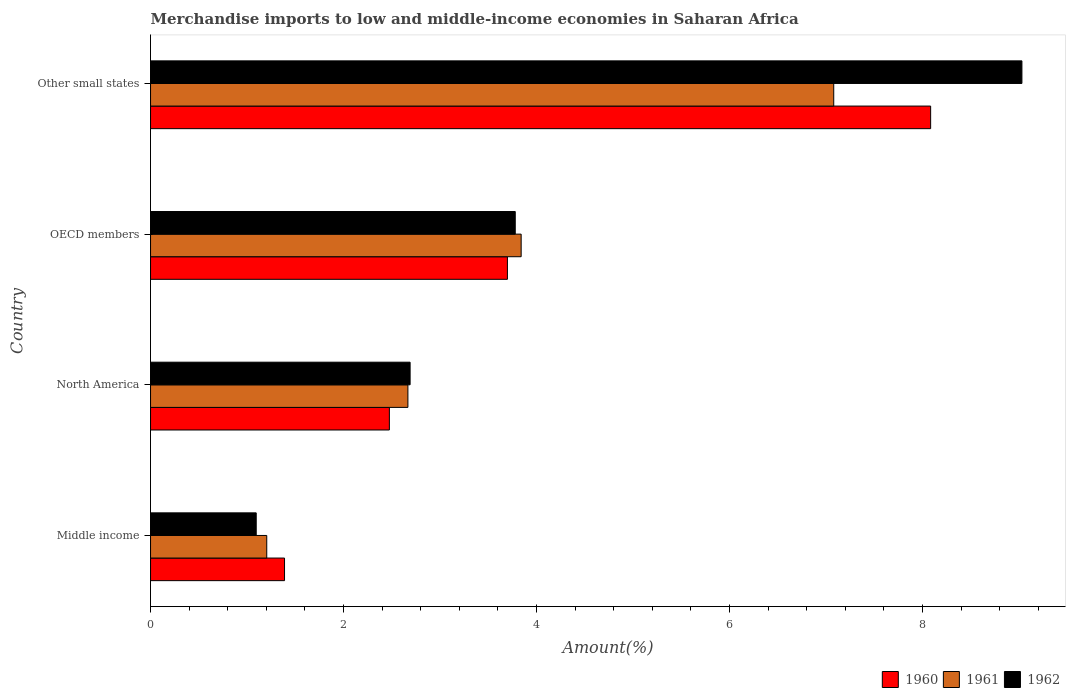How many different coloured bars are there?
Ensure brevity in your answer.  3. How many groups of bars are there?
Make the answer very short. 4. Are the number of bars per tick equal to the number of legend labels?
Keep it short and to the point. Yes. How many bars are there on the 3rd tick from the top?
Keep it short and to the point. 3. What is the label of the 2nd group of bars from the top?
Your response must be concise. OECD members. What is the percentage of amount earned from merchandise imports in 1961 in Middle income?
Your answer should be very brief. 1.2. Across all countries, what is the maximum percentage of amount earned from merchandise imports in 1962?
Offer a terse response. 9.03. Across all countries, what is the minimum percentage of amount earned from merchandise imports in 1960?
Offer a terse response. 1.39. In which country was the percentage of amount earned from merchandise imports in 1962 maximum?
Provide a succinct answer. Other small states. In which country was the percentage of amount earned from merchandise imports in 1961 minimum?
Ensure brevity in your answer.  Middle income. What is the total percentage of amount earned from merchandise imports in 1960 in the graph?
Keep it short and to the point. 15.65. What is the difference between the percentage of amount earned from merchandise imports in 1961 in North America and that in Other small states?
Provide a succinct answer. -4.41. What is the difference between the percentage of amount earned from merchandise imports in 1960 in North America and the percentage of amount earned from merchandise imports in 1961 in OECD members?
Make the answer very short. -1.37. What is the average percentage of amount earned from merchandise imports in 1961 per country?
Offer a terse response. 3.7. What is the difference between the percentage of amount earned from merchandise imports in 1961 and percentage of amount earned from merchandise imports in 1962 in Other small states?
Offer a very short reply. -1.95. What is the ratio of the percentage of amount earned from merchandise imports in 1961 in North America to that in OECD members?
Keep it short and to the point. 0.69. Is the difference between the percentage of amount earned from merchandise imports in 1961 in OECD members and Other small states greater than the difference between the percentage of amount earned from merchandise imports in 1962 in OECD members and Other small states?
Provide a short and direct response. Yes. What is the difference between the highest and the second highest percentage of amount earned from merchandise imports in 1960?
Keep it short and to the point. 4.39. What is the difference between the highest and the lowest percentage of amount earned from merchandise imports in 1960?
Offer a terse response. 6.7. In how many countries, is the percentage of amount earned from merchandise imports in 1960 greater than the average percentage of amount earned from merchandise imports in 1960 taken over all countries?
Give a very brief answer. 1. What does the 3rd bar from the top in Middle income represents?
Offer a terse response. 1960. Is it the case that in every country, the sum of the percentage of amount earned from merchandise imports in 1960 and percentage of amount earned from merchandise imports in 1962 is greater than the percentage of amount earned from merchandise imports in 1961?
Make the answer very short. Yes. What is the difference between two consecutive major ticks on the X-axis?
Make the answer very short. 2. Are the values on the major ticks of X-axis written in scientific E-notation?
Ensure brevity in your answer.  No. How many legend labels are there?
Provide a short and direct response. 3. What is the title of the graph?
Provide a succinct answer. Merchandise imports to low and middle-income economies in Saharan Africa. Does "1983" appear as one of the legend labels in the graph?
Make the answer very short. No. What is the label or title of the X-axis?
Ensure brevity in your answer.  Amount(%). What is the label or title of the Y-axis?
Your answer should be very brief. Country. What is the Amount(%) in 1960 in Middle income?
Your answer should be compact. 1.39. What is the Amount(%) of 1961 in Middle income?
Make the answer very short. 1.2. What is the Amount(%) of 1962 in Middle income?
Keep it short and to the point. 1.1. What is the Amount(%) in 1960 in North America?
Offer a terse response. 2.47. What is the Amount(%) in 1961 in North America?
Provide a succinct answer. 2.67. What is the Amount(%) in 1962 in North America?
Offer a very short reply. 2.69. What is the Amount(%) of 1960 in OECD members?
Your response must be concise. 3.7. What is the Amount(%) of 1961 in OECD members?
Give a very brief answer. 3.84. What is the Amount(%) of 1962 in OECD members?
Ensure brevity in your answer.  3.78. What is the Amount(%) in 1960 in Other small states?
Offer a very short reply. 8.08. What is the Amount(%) of 1961 in Other small states?
Give a very brief answer. 7.08. What is the Amount(%) of 1962 in Other small states?
Offer a very short reply. 9.03. Across all countries, what is the maximum Amount(%) in 1960?
Your answer should be compact. 8.08. Across all countries, what is the maximum Amount(%) in 1961?
Your response must be concise. 7.08. Across all countries, what is the maximum Amount(%) of 1962?
Your response must be concise. 9.03. Across all countries, what is the minimum Amount(%) of 1960?
Your answer should be very brief. 1.39. Across all countries, what is the minimum Amount(%) of 1961?
Make the answer very short. 1.2. Across all countries, what is the minimum Amount(%) of 1962?
Give a very brief answer. 1.1. What is the total Amount(%) in 1960 in the graph?
Your response must be concise. 15.65. What is the total Amount(%) in 1961 in the graph?
Your answer should be very brief. 14.79. What is the total Amount(%) in 1962 in the graph?
Provide a short and direct response. 16.59. What is the difference between the Amount(%) of 1960 in Middle income and that in North America?
Offer a terse response. -1.09. What is the difference between the Amount(%) in 1961 in Middle income and that in North America?
Your response must be concise. -1.46. What is the difference between the Amount(%) in 1962 in Middle income and that in North America?
Offer a terse response. -1.59. What is the difference between the Amount(%) in 1960 in Middle income and that in OECD members?
Your answer should be very brief. -2.31. What is the difference between the Amount(%) in 1961 in Middle income and that in OECD members?
Your answer should be compact. -2.64. What is the difference between the Amount(%) of 1962 in Middle income and that in OECD members?
Your response must be concise. -2.68. What is the difference between the Amount(%) in 1960 in Middle income and that in Other small states?
Provide a short and direct response. -6.7. What is the difference between the Amount(%) in 1961 in Middle income and that in Other small states?
Your answer should be very brief. -5.88. What is the difference between the Amount(%) in 1962 in Middle income and that in Other small states?
Ensure brevity in your answer.  -7.93. What is the difference between the Amount(%) in 1960 in North America and that in OECD members?
Provide a succinct answer. -1.22. What is the difference between the Amount(%) of 1961 in North America and that in OECD members?
Your answer should be very brief. -1.17. What is the difference between the Amount(%) in 1962 in North America and that in OECD members?
Give a very brief answer. -1.09. What is the difference between the Amount(%) of 1960 in North America and that in Other small states?
Your response must be concise. -5.61. What is the difference between the Amount(%) of 1961 in North America and that in Other small states?
Ensure brevity in your answer.  -4.41. What is the difference between the Amount(%) of 1962 in North America and that in Other small states?
Make the answer very short. -6.34. What is the difference between the Amount(%) of 1960 in OECD members and that in Other small states?
Offer a terse response. -4.39. What is the difference between the Amount(%) of 1961 in OECD members and that in Other small states?
Your answer should be very brief. -3.24. What is the difference between the Amount(%) in 1962 in OECD members and that in Other small states?
Offer a very short reply. -5.25. What is the difference between the Amount(%) in 1960 in Middle income and the Amount(%) in 1961 in North America?
Keep it short and to the point. -1.28. What is the difference between the Amount(%) in 1960 in Middle income and the Amount(%) in 1962 in North America?
Offer a terse response. -1.3. What is the difference between the Amount(%) of 1961 in Middle income and the Amount(%) of 1962 in North America?
Keep it short and to the point. -1.49. What is the difference between the Amount(%) in 1960 in Middle income and the Amount(%) in 1961 in OECD members?
Offer a terse response. -2.45. What is the difference between the Amount(%) in 1960 in Middle income and the Amount(%) in 1962 in OECD members?
Keep it short and to the point. -2.39. What is the difference between the Amount(%) of 1961 in Middle income and the Amount(%) of 1962 in OECD members?
Your response must be concise. -2.58. What is the difference between the Amount(%) of 1960 in Middle income and the Amount(%) of 1961 in Other small states?
Your answer should be compact. -5.69. What is the difference between the Amount(%) in 1960 in Middle income and the Amount(%) in 1962 in Other small states?
Your answer should be very brief. -7.64. What is the difference between the Amount(%) of 1961 in Middle income and the Amount(%) of 1962 in Other small states?
Ensure brevity in your answer.  -7.83. What is the difference between the Amount(%) of 1960 in North America and the Amount(%) of 1961 in OECD members?
Give a very brief answer. -1.37. What is the difference between the Amount(%) of 1960 in North America and the Amount(%) of 1962 in OECD members?
Offer a very short reply. -1.3. What is the difference between the Amount(%) in 1961 in North America and the Amount(%) in 1962 in OECD members?
Your answer should be compact. -1.11. What is the difference between the Amount(%) in 1960 in North America and the Amount(%) in 1961 in Other small states?
Ensure brevity in your answer.  -4.6. What is the difference between the Amount(%) of 1960 in North America and the Amount(%) of 1962 in Other small states?
Offer a terse response. -6.55. What is the difference between the Amount(%) in 1961 in North America and the Amount(%) in 1962 in Other small states?
Make the answer very short. -6.36. What is the difference between the Amount(%) in 1960 in OECD members and the Amount(%) in 1961 in Other small states?
Make the answer very short. -3.38. What is the difference between the Amount(%) in 1960 in OECD members and the Amount(%) in 1962 in Other small states?
Your answer should be compact. -5.33. What is the difference between the Amount(%) of 1961 in OECD members and the Amount(%) of 1962 in Other small states?
Ensure brevity in your answer.  -5.19. What is the average Amount(%) of 1960 per country?
Offer a very short reply. 3.91. What is the average Amount(%) in 1961 per country?
Keep it short and to the point. 3.7. What is the average Amount(%) of 1962 per country?
Provide a succinct answer. 4.15. What is the difference between the Amount(%) of 1960 and Amount(%) of 1961 in Middle income?
Provide a succinct answer. 0.18. What is the difference between the Amount(%) in 1960 and Amount(%) in 1962 in Middle income?
Offer a very short reply. 0.29. What is the difference between the Amount(%) in 1961 and Amount(%) in 1962 in Middle income?
Your answer should be very brief. 0.11. What is the difference between the Amount(%) in 1960 and Amount(%) in 1961 in North America?
Your answer should be compact. -0.19. What is the difference between the Amount(%) in 1960 and Amount(%) in 1962 in North America?
Offer a terse response. -0.21. What is the difference between the Amount(%) of 1961 and Amount(%) of 1962 in North America?
Your answer should be compact. -0.02. What is the difference between the Amount(%) of 1960 and Amount(%) of 1961 in OECD members?
Your response must be concise. -0.14. What is the difference between the Amount(%) in 1960 and Amount(%) in 1962 in OECD members?
Provide a succinct answer. -0.08. What is the difference between the Amount(%) of 1961 and Amount(%) of 1962 in OECD members?
Offer a terse response. 0.06. What is the difference between the Amount(%) in 1960 and Amount(%) in 1961 in Other small states?
Your response must be concise. 1. What is the difference between the Amount(%) in 1960 and Amount(%) in 1962 in Other small states?
Keep it short and to the point. -0.95. What is the difference between the Amount(%) of 1961 and Amount(%) of 1962 in Other small states?
Offer a very short reply. -1.95. What is the ratio of the Amount(%) of 1960 in Middle income to that in North America?
Ensure brevity in your answer.  0.56. What is the ratio of the Amount(%) of 1961 in Middle income to that in North America?
Keep it short and to the point. 0.45. What is the ratio of the Amount(%) of 1962 in Middle income to that in North America?
Your answer should be compact. 0.41. What is the ratio of the Amount(%) in 1960 in Middle income to that in OECD members?
Make the answer very short. 0.38. What is the ratio of the Amount(%) in 1961 in Middle income to that in OECD members?
Provide a succinct answer. 0.31. What is the ratio of the Amount(%) in 1962 in Middle income to that in OECD members?
Ensure brevity in your answer.  0.29. What is the ratio of the Amount(%) in 1960 in Middle income to that in Other small states?
Offer a terse response. 0.17. What is the ratio of the Amount(%) of 1961 in Middle income to that in Other small states?
Make the answer very short. 0.17. What is the ratio of the Amount(%) in 1962 in Middle income to that in Other small states?
Keep it short and to the point. 0.12. What is the ratio of the Amount(%) in 1960 in North America to that in OECD members?
Provide a short and direct response. 0.67. What is the ratio of the Amount(%) of 1961 in North America to that in OECD members?
Your answer should be compact. 0.69. What is the ratio of the Amount(%) of 1962 in North America to that in OECD members?
Ensure brevity in your answer.  0.71. What is the ratio of the Amount(%) of 1960 in North America to that in Other small states?
Keep it short and to the point. 0.31. What is the ratio of the Amount(%) of 1961 in North America to that in Other small states?
Your answer should be compact. 0.38. What is the ratio of the Amount(%) of 1962 in North America to that in Other small states?
Offer a very short reply. 0.3. What is the ratio of the Amount(%) of 1960 in OECD members to that in Other small states?
Offer a terse response. 0.46. What is the ratio of the Amount(%) of 1961 in OECD members to that in Other small states?
Ensure brevity in your answer.  0.54. What is the ratio of the Amount(%) in 1962 in OECD members to that in Other small states?
Keep it short and to the point. 0.42. What is the difference between the highest and the second highest Amount(%) in 1960?
Your answer should be very brief. 4.39. What is the difference between the highest and the second highest Amount(%) of 1961?
Make the answer very short. 3.24. What is the difference between the highest and the second highest Amount(%) in 1962?
Your response must be concise. 5.25. What is the difference between the highest and the lowest Amount(%) in 1960?
Your answer should be very brief. 6.7. What is the difference between the highest and the lowest Amount(%) of 1961?
Offer a very short reply. 5.88. What is the difference between the highest and the lowest Amount(%) of 1962?
Your response must be concise. 7.93. 